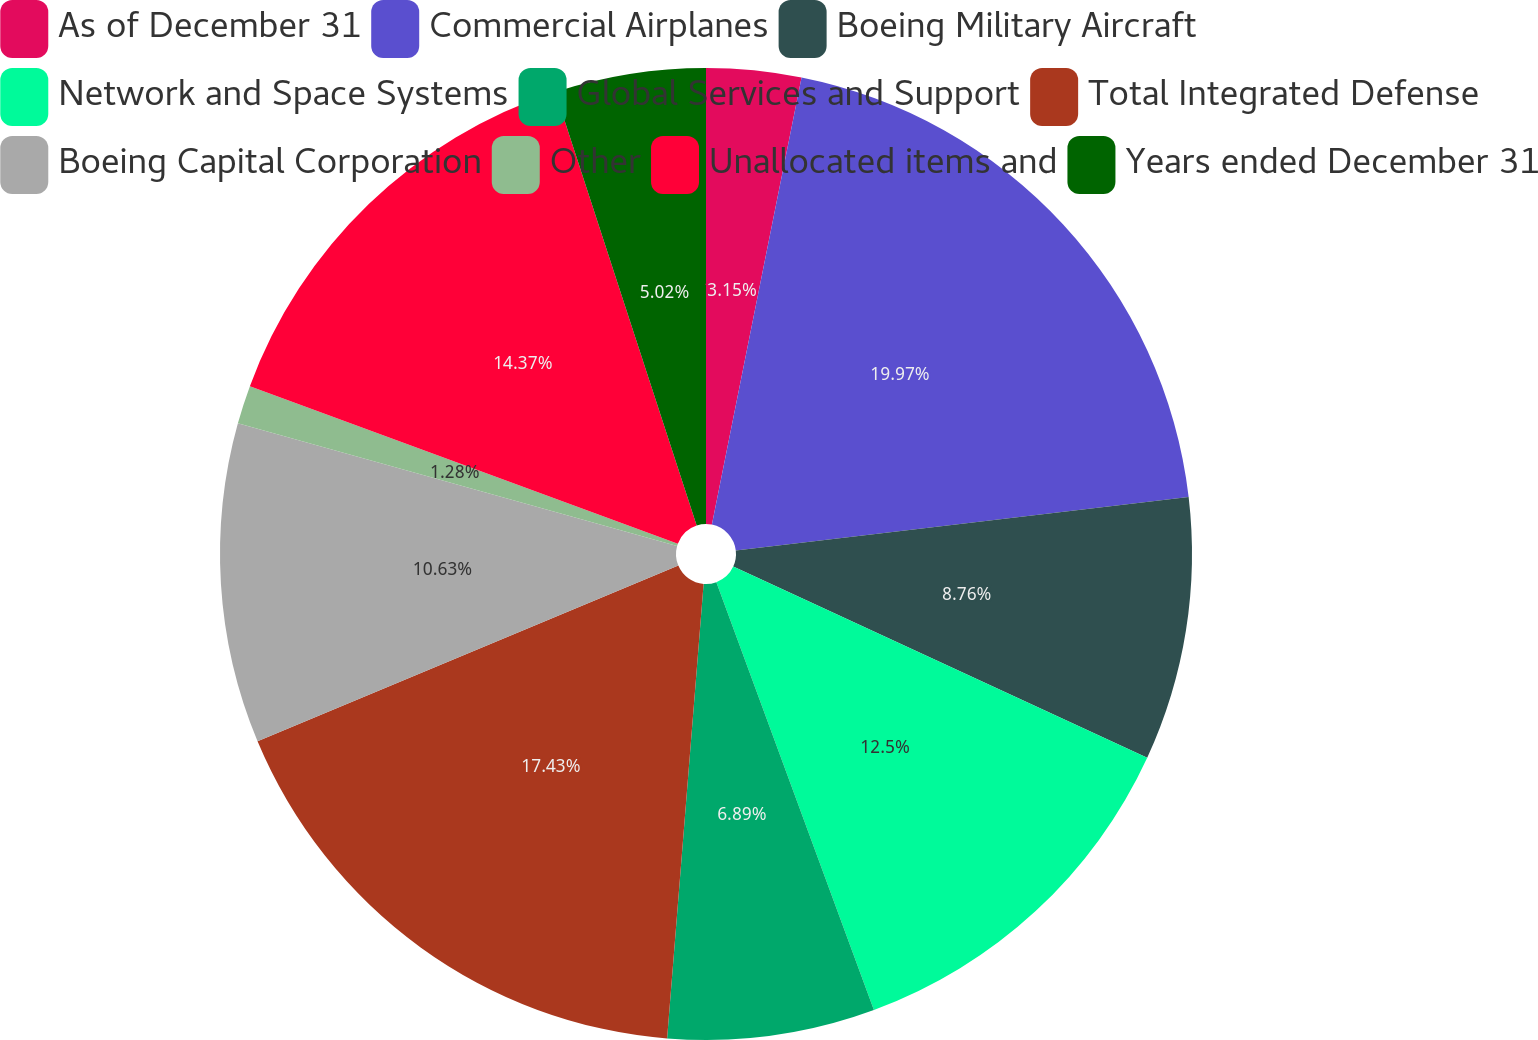Convert chart to OTSL. <chart><loc_0><loc_0><loc_500><loc_500><pie_chart><fcel>As of December 31<fcel>Commercial Airplanes<fcel>Boeing Military Aircraft<fcel>Network and Space Systems<fcel>Global Services and Support<fcel>Total Integrated Defense<fcel>Boeing Capital Corporation<fcel>Other<fcel>Unallocated items and<fcel>Years ended December 31<nl><fcel>3.15%<fcel>19.98%<fcel>8.76%<fcel>12.5%<fcel>6.89%<fcel>17.43%<fcel>10.63%<fcel>1.28%<fcel>14.37%<fcel>5.02%<nl></chart> 